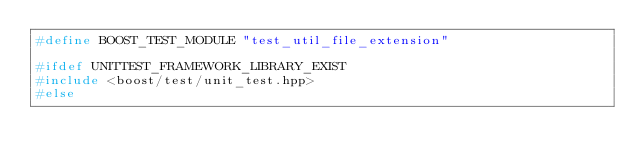Convert code to text. <code><loc_0><loc_0><loc_500><loc_500><_C++_>#define BOOST_TEST_MODULE "test_util_file_extension"

#ifdef UNITTEST_FRAMEWORK_LIBRARY_EXIST
#include <boost/test/unit_test.hpp>
#else</code> 